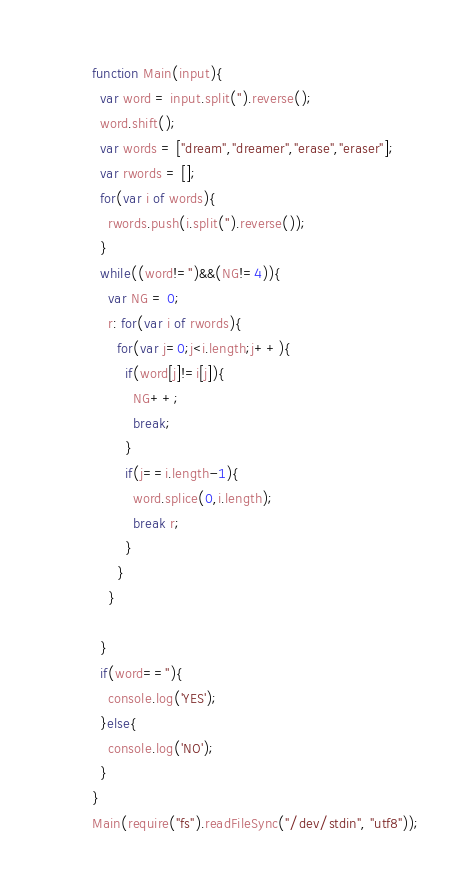Convert code to text. <code><loc_0><loc_0><loc_500><loc_500><_JavaScript_>function Main(input){
  var word = input.split('').reverse();
  word.shift();
  var words = ["dream","dreamer","erase","eraser"];
  var rwords = [];
  for(var i of words){
    rwords.push(i.split('').reverse());
  }
  while((word!='')&&(NG!=4)){
    var NG = 0;
    r: for(var i of rwords){
      for(var j=0;j<i.length;j++){
        if(word[j]!=i[j]){
          NG++;
          break;
        }
        if(j==i.length-1){
          word.splice(0,i.length);
          break r;
        }
      }
    }

  }
  if(word==''){
    console.log('YES');
  }else{
    console.log('NO');
  }
}
Main(require("fs").readFileSync("/dev/stdin", "utf8"));</code> 